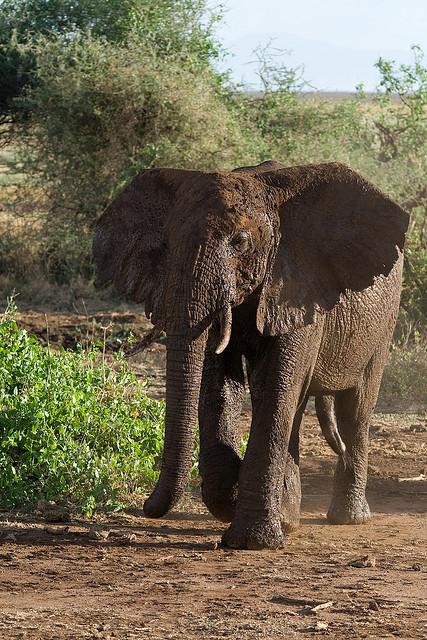Are there trees behind the elephant?
Concise answer only. Yes. What was used to make piano keys?
Short answer required. Ivory. What is the elephant covered in?
Quick response, please. Mud. 